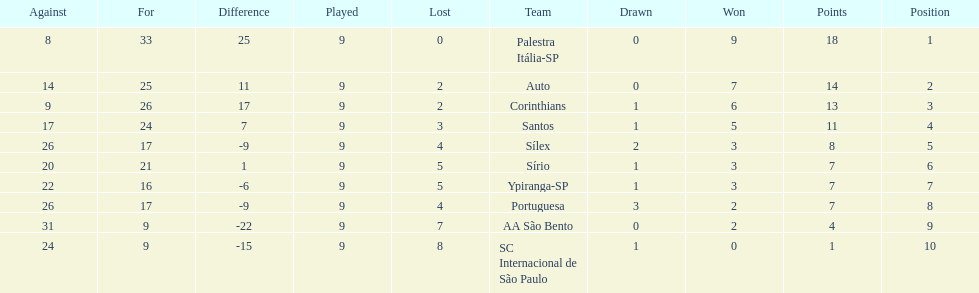Which brazilian team took the top spot in the 1926 brazilian football cup? Palestra Itália-SP. 